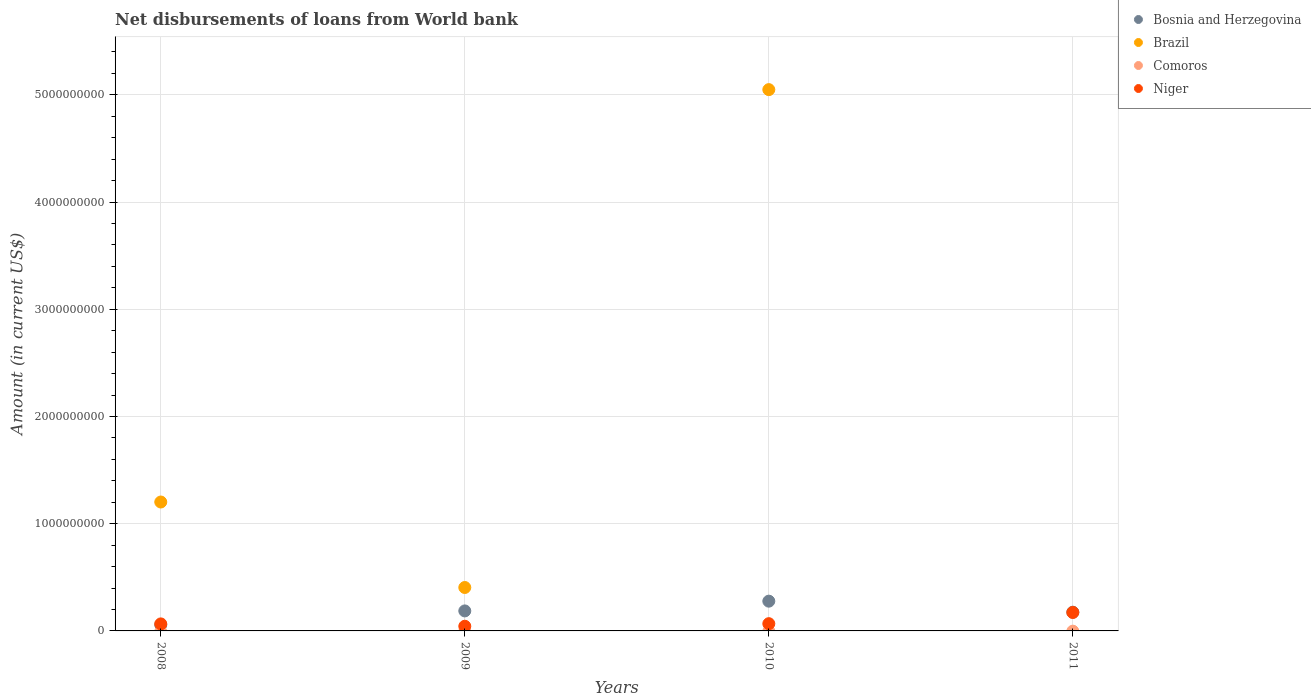How many different coloured dotlines are there?
Give a very brief answer. 3. Is the number of dotlines equal to the number of legend labels?
Offer a terse response. No. What is the amount of loan disbursed from World Bank in Niger in 2009?
Make the answer very short. 4.36e+07. Across all years, what is the maximum amount of loan disbursed from World Bank in Bosnia and Herzegovina?
Provide a short and direct response. 2.78e+08. Across all years, what is the minimum amount of loan disbursed from World Bank in Bosnia and Herzegovina?
Offer a terse response. 5.72e+07. In which year was the amount of loan disbursed from World Bank in Brazil maximum?
Your answer should be compact. 2010. What is the total amount of loan disbursed from World Bank in Bosnia and Herzegovina in the graph?
Ensure brevity in your answer.  6.96e+08. What is the difference between the amount of loan disbursed from World Bank in Brazil in 2009 and that in 2010?
Provide a short and direct response. -4.64e+09. What is the difference between the amount of loan disbursed from World Bank in Bosnia and Herzegovina in 2010 and the amount of loan disbursed from World Bank in Brazil in 2009?
Provide a short and direct response. -1.27e+08. What is the average amount of loan disbursed from World Bank in Comoros per year?
Ensure brevity in your answer.  0. In the year 2008, what is the difference between the amount of loan disbursed from World Bank in Niger and amount of loan disbursed from World Bank in Bosnia and Herzegovina?
Provide a succinct answer. 8.39e+06. What is the ratio of the amount of loan disbursed from World Bank in Bosnia and Herzegovina in 2009 to that in 2010?
Ensure brevity in your answer.  0.67. Is the difference between the amount of loan disbursed from World Bank in Niger in 2008 and 2010 greater than the difference between the amount of loan disbursed from World Bank in Bosnia and Herzegovina in 2008 and 2010?
Offer a very short reply. Yes. What is the difference between the highest and the second highest amount of loan disbursed from World Bank in Niger?
Provide a succinct answer. 1.04e+08. What is the difference between the highest and the lowest amount of loan disbursed from World Bank in Brazil?
Offer a terse response. 5.05e+09. In how many years, is the amount of loan disbursed from World Bank in Bosnia and Herzegovina greater than the average amount of loan disbursed from World Bank in Bosnia and Herzegovina taken over all years?
Make the answer very short. 3. Is the sum of the amount of loan disbursed from World Bank in Bosnia and Herzegovina in 2008 and 2011 greater than the maximum amount of loan disbursed from World Bank in Comoros across all years?
Give a very brief answer. Yes. Is the amount of loan disbursed from World Bank in Brazil strictly greater than the amount of loan disbursed from World Bank in Bosnia and Herzegovina over the years?
Provide a short and direct response. No. Is the amount of loan disbursed from World Bank in Comoros strictly less than the amount of loan disbursed from World Bank in Bosnia and Herzegovina over the years?
Offer a terse response. Yes. How many dotlines are there?
Keep it short and to the point. 3. Does the graph contain any zero values?
Provide a short and direct response. Yes. How many legend labels are there?
Give a very brief answer. 4. What is the title of the graph?
Offer a very short reply. Net disbursements of loans from World bank. What is the label or title of the X-axis?
Your answer should be very brief. Years. What is the Amount (in current US$) of Bosnia and Herzegovina in 2008?
Offer a very short reply. 5.72e+07. What is the Amount (in current US$) of Brazil in 2008?
Provide a succinct answer. 1.20e+09. What is the Amount (in current US$) in Comoros in 2008?
Give a very brief answer. 0. What is the Amount (in current US$) of Niger in 2008?
Your answer should be compact. 6.56e+07. What is the Amount (in current US$) in Bosnia and Herzegovina in 2009?
Give a very brief answer. 1.87e+08. What is the Amount (in current US$) of Brazil in 2009?
Keep it short and to the point. 4.05e+08. What is the Amount (in current US$) in Comoros in 2009?
Your answer should be compact. 0. What is the Amount (in current US$) of Niger in 2009?
Provide a short and direct response. 4.36e+07. What is the Amount (in current US$) in Bosnia and Herzegovina in 2010?
Make the answer very short. 2.78e+08. What is the Amount (in current US$) in Brazil in 2010?
Your answer should be very brief. 5.05e+09. What is the Amount (in current US$) in Comoros in 2010?
Offer a very short reply. 0. What is the Amount (in current US$) in Niger in 2010?
Ensure brevity in your answer.  6.76e+07. What is the Amount (in current US$) in Bosnia and Herzegovina in 2011?
Offer a terse response. 1.75e+08. What is the Amount (in current US$) of Niger in 2011?
Offer a terse response. 1.72e+08. Across all years, what is the maximum Amount (in current US$) of Bosnia and Herzegovina?
Ensure brevity in your answer.  2.78e+08. Across all years, what is the maximum Amount (in current US$) in Brazil?
Give a very brief answer. 5.05e+09. Across all years, what is the maximum Amount (in current US$) in Niger?
Your answer should be compact. 1.72e+08. Across all years, what is the minimum Amount (in current US$) in Bosnia and Herzegovina?
Your answer should be compact. 5.72e+07. Across all years, what is the minimum Amount (in current US$) of Brazil?
Give a very brief answer. 0. Across all years, what is the minimum Amount (in current US$) of Niger?
Make the answer very short. 4.36e+07. What is the total Amount (in current US$) of Bosnia and Herzegovina in the graph?
Your answer should be compact. 6.96e+08. What is the total Amount (in current US$) of Brazil in the graph?
Keep it short and to the point. 6.66e+09. What is the total Amount (in current US$) in Comoros in the graph?
Offer a very short reply. 0. What is the total Amount (in current US$) of Niger in the graph?
Provide a succinct answer. 3.49e+08. What is the difference between the Amount (in current US$) of Bosnia and Herzegovina in 2008 and that in 2009?
Ensure brevity in your answer.  -1.29e+08. What is the difference between the Amount (in current US$) in Brazil in 2008 and that in 2009?
Your answer should be very brief. 7.97e+08. What is the difference between the Amount (in current US$) in Niger in 2008 and that in 2009?
Provide a short and direct response. 2.20e+07. What is the difference between the Amount (in current US$) in Bosnia and Herzegovina in 2008 and that in 2010?
Your answer should be very brief. -2.20e+08. What is the difference between the Amount (in current US$) of Brazil in 2008 and that in 2010?
Make the answer very short. -3.85e+09. What is the difference between the Amount (in current US$) in Niger in 2008 and that in 2010?
Offer a terse response. -2.05e+06. What is the difference between the Amount (in current US$) in Bosnia and Herzegovina in 2008 and that in 2011?
Offer a terse response. -1.18e+08. What is the difference between the Amount (in current US$) in Niger in 2008 and that in 2011?
Your response must be concise. -1.06e+08. What is the difference between the Amount (in current US$) of Bosnia and Herzegovina in 2009 and that in 2010?
Your response must be concise. -9.10e+07. What is the difference between the Amount (in current US$) in Brazil in 2009 and that in 2010?
Make the answer very short. -4.64e+09. What is the difference between the Amount (in current US$) of Niger in 2009 and that in 2010?
Keep it short and to the point. -2.40e+07. What is the difference between the Amount (in current US$) of Bosnia and Herzegovina in 2009 and that in 2011?
Give a very brief answer. 1.18e+07. What is the difference between the Amount (in current US$) in Niger in 2009 and that in 2011?
Your response must be concise. -1.28e+08. What is the difference between the Amount (in current US$) of Bosnia and Herzegovina in 2010 and that in 2011?
Offer a very short reply. 1.03e+08. What is the difference between the Amount (in current US$) in Niger in 2010 and that in 2011?
Your answer should be compact. -1.04e+08. What is the difference between the Amount (in current US$) of Bosnia and Herzegovina in 2008 and the Amount (in current US$) of Brazil in 2009?
Give a very brief answer. -3.48e+08. What is the difference between the Amount (in current US$) in Bosnia and Herzegovina in 2008 and the Amount (in current US$) in Niger in 2009?
Offer a very short reply. 1.36e+07. What is the difference between the Amount (in current US$) of Brazil in 2008 and the Amount (in current US$) of Niger in 2009?
Provide a succinct answer. 1.16e+09. What is the difference between the Amount (in current US$) of Bosnia and Herzegovina in 2008 and the Amount (in current US$) of Brazil in 2010?
Offer a terse response. -4.99e+09. What is the difference between the Amount (in current US$) in Bosnia and Herzegovina in 2008 and the Amount (in current US$) in Niger in 2010?
Keep it short and to the point. -1.04e+07. What is the difference between the Amount (in current US$) of Brazil in 2008 and the Amount (in current US$) of Niger in 2010?
Provide a succinct answer. 1.13e+09. What is the difference between the Amount (in current US$) of Bosnia and Herzegovina in 2008 and the Amount (in current US$) of Niger in 2011?
Ensure brevity in your answer.  -1.15e+08. What is the difference between the Amount (in current US$) in Brazil in 2008 and the Amount (in current US$) in Niger in 2011?
Give a very brief answer. 1.03e+09. What is the difference between the Amount (in current US$) of Bosnia and Herzegovina in 2009 and the Amount (in current US$) of Brazil in 2010?
Your answer should be compact. -4.86e+09. What is the difference between the Amount (in current US$) of Bosnia and Herzegovina in 2009 and the Amount (in current US$) of Niger in 2010?
Your response must be concise. 1.19e+08. What is the difference between the Amount (in current US$) of Brazil in 2009 and the Amount (in current US$) of Niger in 2010?
Offer a terse response. 3.37e+08. What is the difference between the Amount (in current US$) in Bosnia and Herzegovina in 2009 and the Amount (in current US$) in Niger in 2011?
Offer a terse response. 1.46e+07. What is the difference between the Amount (in current US$) of Brazil in 2009 and the Amount (in current US$) of Niger in 2011?
Ensure brevity in your answer.  2.33e+08. What is the difference between the Amount (in current US$) of Bosnia and Herzegovina in 2010 and the Amount (in current US$) of Niger in 2011?
Your answer should be compact. 1.06e+08. What is the difference between the Amount (in current US$) of Brazil in 2010 and the Amount (in current US$) of Niger in 2011?
Offer a terse response. 4.88e+09. What is the average Amount (in current US$) in Bosnia and Herzegovina per year?
Offer a terse response. 1.74e+08. What is the average Amount (in current US$) in Brazil per year?
Ensure brevity in your answer.  1.66e+09. What is the average Amount (in current US$) of Comoros per year?
Your answer should be compact. 0. What is the average Amount (in current US$) in Niger per year?
Ensure brevity in your answer.  8.72e+07. In the year 2008, what is the difference between the Amount (in current US$) in Bosnia and Herzegovina and Amount (in current US$) in Brazil?
Offer a very short reply. -1.15e+09. In the year 2008, what is the difference between the Amount (in current US$) of Bosnia and Herzegovina and Amount (in current US$) of Niger?
Offer a terse response. -8.39e+06. In the year 2008, what is the difference between the Amount (in current US$) of Brazil and Amount (in current US$) of Niger?
Your response must be concise. 1.14e+09. In the year 2009, what is the difference between the Amount (in current US$) in Bosnia and Herzegovina and Amount (in current US$) in Brazil?
Offer a terse response. -2.18e+08. In the year 2009, what is the difference between the Amount (in current US$) in Bosnia and Herzegovina and Amount (in current US$) in Niger?
Make the answer very short. 1.43e+08. In the year 2009, what is the difference between the Amount (in current US$) of Brazil and Amount (in current US$) of Niger?
Keep it short and to the point. 3.61e+08. In the year 2010, what is the difference between the Amount (in current US$) in Bosnia and Herzegovina and Amount (in current US$) in Brazil?
Provide a succinct answer. -4.77e+09. In the year 2010, what is the difference between the Amount (in current US$) of Bosnia and Herzegovina and Amount (in current US$) of Niger?
Make the answer very short. 2.10e+08. In the year 2010, what is the difference between the Amount (in current US$) in Brazil and Amount (in current US$) in Niger?
Ensure brevity in your answer.  4.98e+09. In the year 2011, what is the difference between the Amount (in current US$) of Bosnia and Herzegovina and Amount (in current US$) of Niger?
Make the answer very short. 2.86e+06. What is the ratio of the Amount (in current US$) in Bosnia and Herzegovina in 2008 to that in 2009?
Give a very brief answer. 0.31. What is the ratio of the Amount (in current US$) in Brazil in 2008 to that in 2009?
Make the answer very short. 2.97. What is the ratio of the Amount (in current US$) in Niger in 2008 to that in 2009?
Give a very brief answer. 1.5. What is the ratio of the Amount (in current US$) in Bosnia and Herzegovina in 2008 to that in 2010?
Provide a short and direct response. 0.21. What is the ratio of the Amount (in current US$) of Brazil in 2008 to that in 2010?
Give a very brief answer. 0.24. What is the ratio of the Amount (in current US$) of Niger in 2008 to that in 2010?
Offer a terse response. 0.97. What is the ratio of the Amount (in current US$) in Bosnia and Herzegovina in 2008 to that in 2011?
Give a very brief answer. 0.33. What is the ratio of the Amount (in current US$) in Niger in 2008 to that in 2011?
Provide a short and direct response. 0.38. What is the ratio of the Amount (in current US$) of Bosnia and Herzegovina in 2009 to that in 2010?
Provide a succinct answer. 0.67. What is the ratio of the Amount (in current US$) of Brazil in 2009 to that in 2010?
Give a very brief answer. 0.08. What is the ratio of the Amount (in current US$) in Niger in 2009 to that in 2010?
Offer a very short reply. 0.64. What is the ratio of the Amount (in current US$) in Bosnia and Herzegovina in 2009 to that in 2011?
Make the answer very short. 1.07. What is the ratio of the Amount (in current US$) of Niger in 2009 to that in 2011?
Offer a very short reply. 0.25. What is the ratio of the Amount (in current US$) in Bosnia and Herzegovina in 2010 to that in 2011?
Give a very brief answer. 1.59. What is the ratio of the Amount (in current US$) in Niger in 2010 to that in 2011?
Make the answer very short. 0.39. What is the difference between the highest and the second highest Amount (in current US$) of Bosnia and Herzegovina?
Keep it short and to the point. 9.10e+07. What is the difference between the highest and the second highest Amount (in current US$) in Brazil?
Ensure brevity in your answer.  3.85e+09. What is the difference between the highest and the second highest Amount (in current US$) in Niger?
Provide a short and direct response. 1.04e+08. What is the difference between the highest and the lowest Amount (in current US$) of Bosnia and Herzegovina?
Keep it short and to the point. 2.20e+08. What is the difference between the highest and the lowest Amount (in current US$) in Brazil?
Offer a terse response. 5.05e+09. What is the difference between the highest and the lowest Amount (in current US$) of Niger?
Provide a succinct answer. 1.28e+08. 